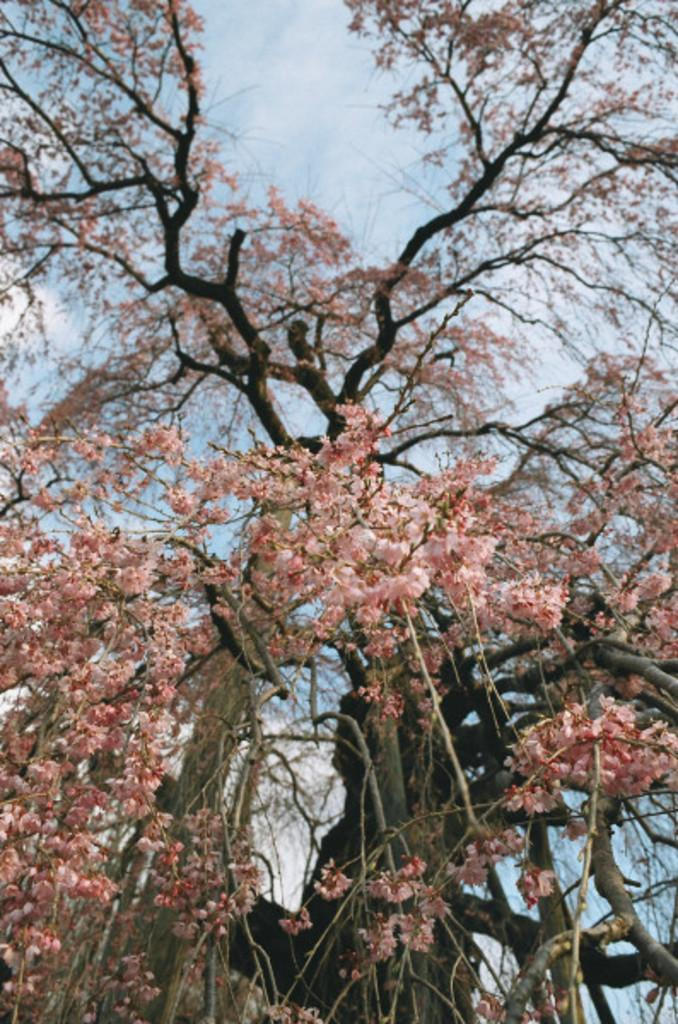What is the main subject in the center of the image? There is a tree in the center of the image. What can be observed on the tree? The tree has flowers. What is visible at the top of the image? The sky is visible at the top of the image. How many snakes are wrapped around the tree in the image? There are no snakes present in the image; the tree has flowers. What adjustment can be made to the tree to make it grow faster? The image does not provide information about how to make the tree grow faster, nor does it suggest any adjustments that could be made. 